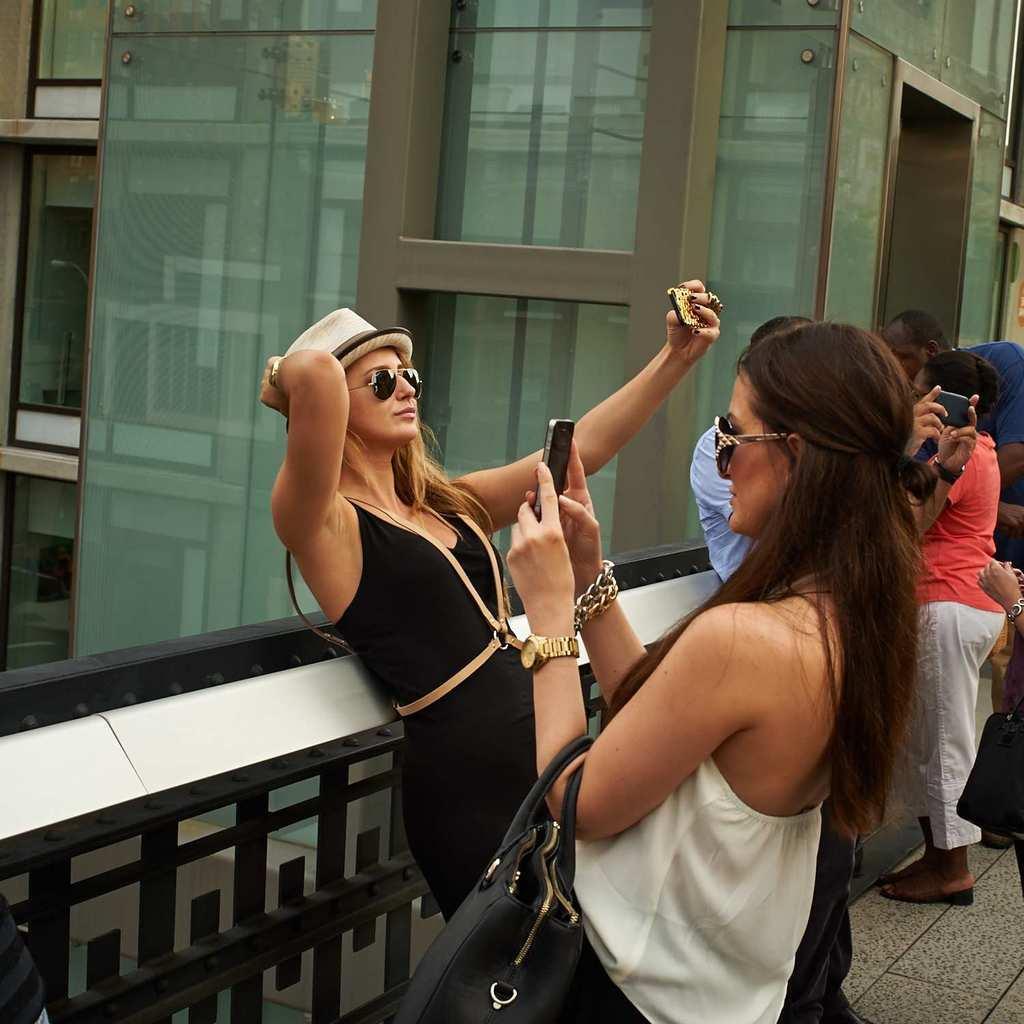How would you summarize this image in a sentence or two? In this image in the center there are some people who are standing and some of them are holding mobiles and clicking pictures. In the foreground the woman who is standing and she is holding a bag, in the background there are some buildings. 